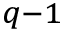Convert formula to latex. <formula><loc_0><loc_0><loc_500><loc_500>_ { q - 1 }</formula> 